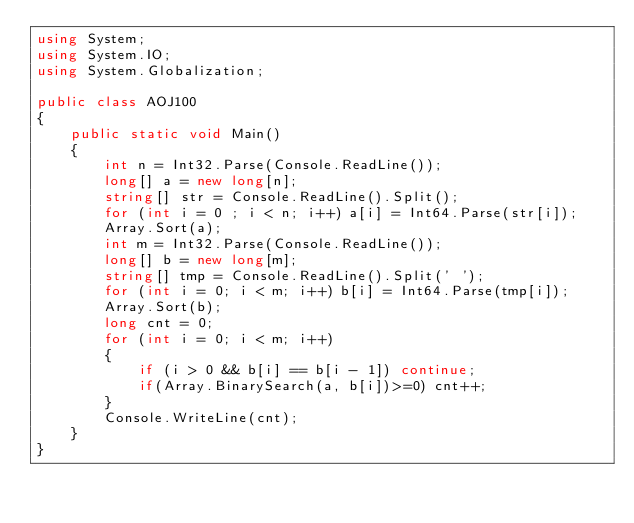Convert code to text. <code><loc_0><loc_0><loc_500><loc_500><_C#_>using System;
using System.IO;
using System.Globalization;

public class AOJ100
{
    public static void Main()
    {
        int n = Int32.Parse(Console.ReadLine());
        long[] a = new long[n];
        string[] str = Console.ReadLine().Split();
        for (int i = 0 ; i < n; i++) a[i] = Int64.Parse(str[i]);
        Array.Sort(a);
        int m = Int32.Parse(Console.ReadLine());
        long[] b = new long[m];
        string[] tmp = Console.ReadLine().Split(' ');
        for (int i = 0; i < m; i++) b[i] = Int64.Parse(tmp[i]);
        Array.Sort(b);
        long cnt = 0;
        for (int i = 0; i < m; i++)
        {
            if (i > 0 && b[i] == b[i - 1]) continue;
            if(Array.BinarySearch(a, b[i])>=0) cnt++;
        }
        Console.WriteLine(cnt);
    }
}</code> 